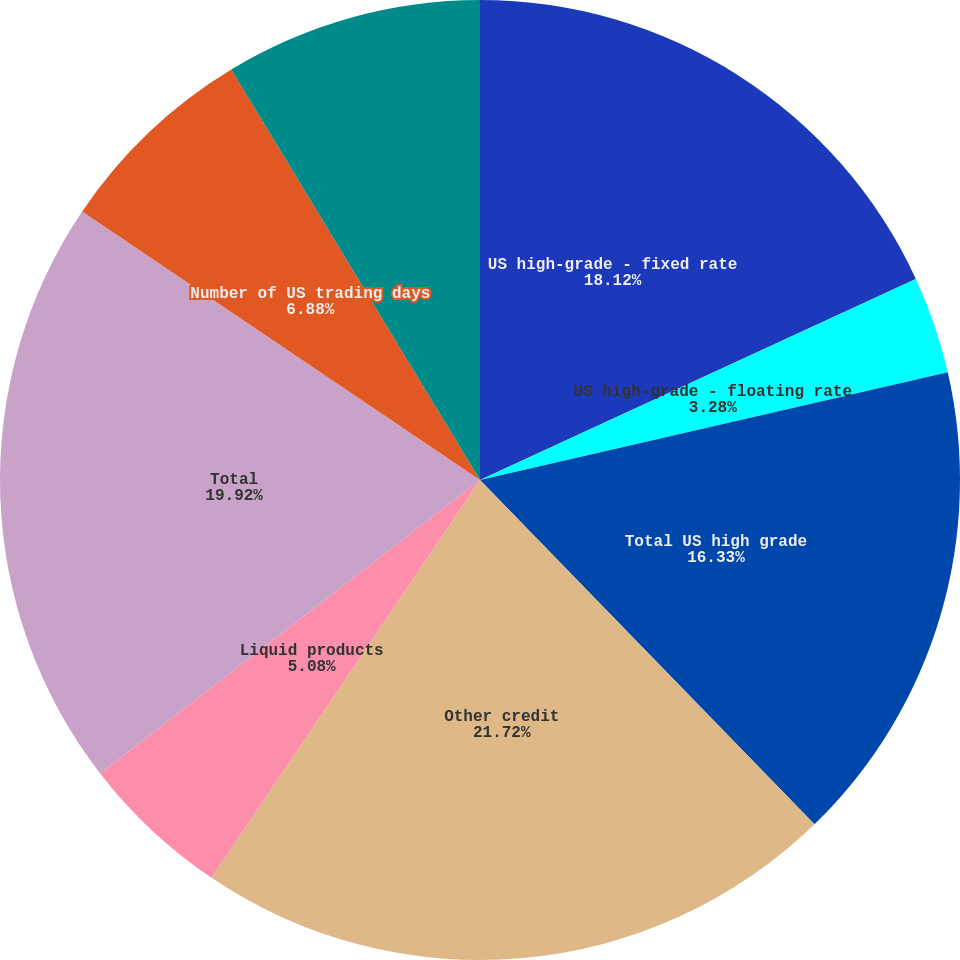Convert chart. <chart><loc_0><loc_0><loc_500><loc_500><pie_chart><fcel>US high-grade - fixed rate<fcel>US high-grade - floating rate<fcel>Total US high grade<fcel>Other credit<fcel>Liquid products<fcel>Total<fcel>Number of US trading days<fcel>Number of UK trading days<nl><fcel>18.12%<fcel>3.28%<fcel>16.33%<fcel>21.72%<fcel>5.08%<fcel>19.92%<fcel>6.88%<fcel>8.67%<nl></chart> 